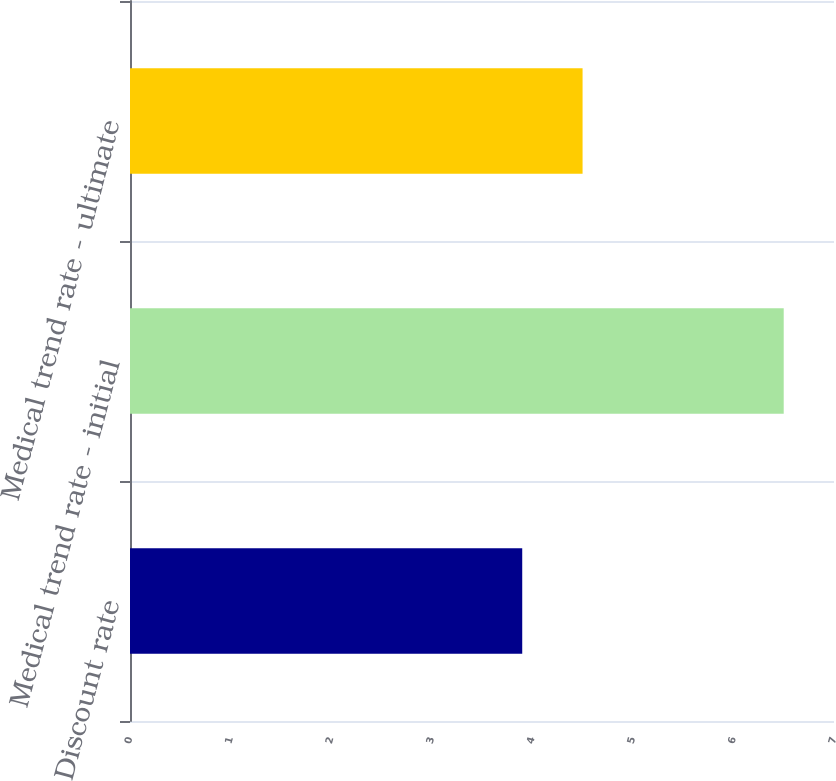<chart> <loc_0><loc_0><loc_500><loc_500><bar_chart><fcel>Discount rate<fcel>Medical trend rate - initial<fcel>Medical trend rate - ultimate<nl><fcel>3.9<fcel>6.5<fcel>4.5<nl></chart> 